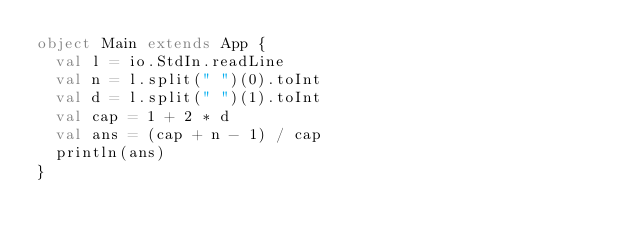<code> <loc_0><loc_0><loc_500><loc_500><_Scala_>object Main extends App {
  val l = io.StdIn.readLine
  val n = l.split(" ")(0).toInt
  val d = l.split(" ")(1).toInt
  val cap = 1 + 2 * d
  val ans = (cap + n - 1) / cap
  println(ans)
}
</code> 